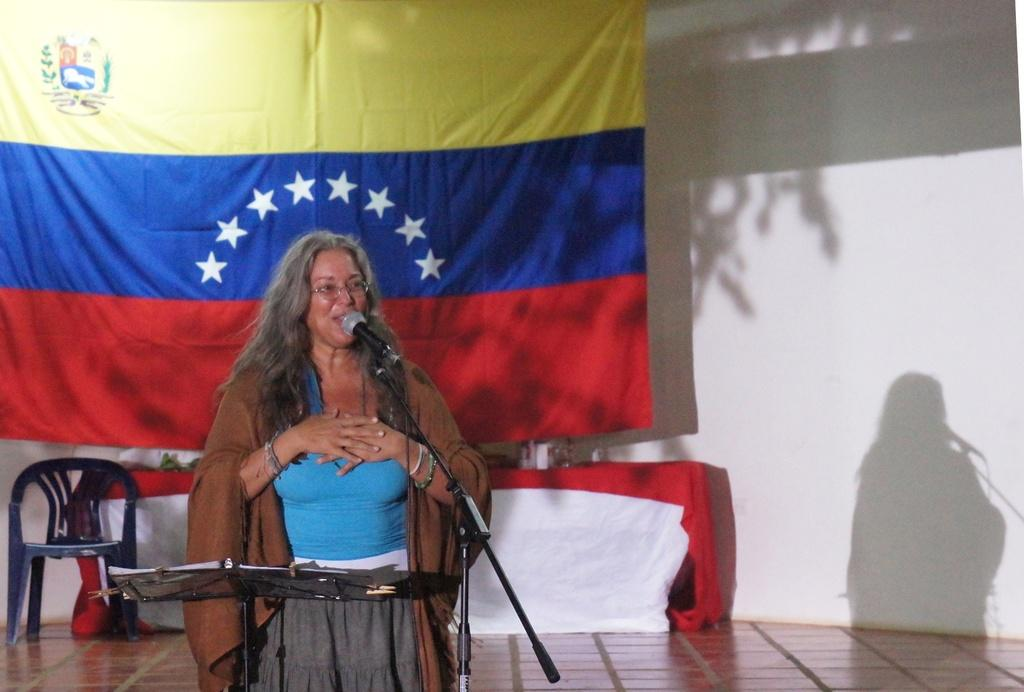Who is the main subject in the image? There is a woman in the image. What is the woman doing in the image? The woman is standing and speaking in front of a mic. What is in front of the woman? There is a stand in front of the woman. What is visible behind the woman? There is a flag behind the woman. How many clams are visible on the stand in the image? There are no clams present in the image; the stand is empty. 